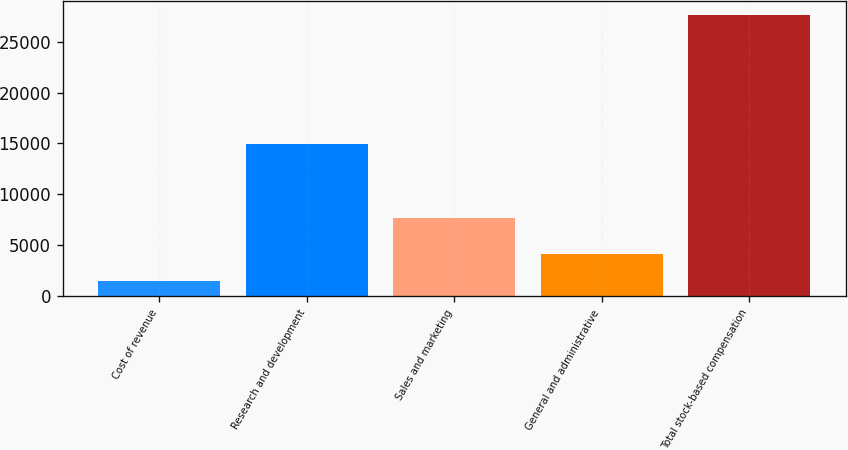Convert chart to OTSL. <chart><loc_0><loc_0><loc_500><loc_500><bar_chart><fcel>Cost of revenue<fcel>Research and development<fcel>Sales and marketing<fcel>General and administrative<fcel>Total stock-based compensation<nl><fcel>1535<fcel>14986<fcel>7643<fcel>4143.4<fcel>27619<nl></chart> 